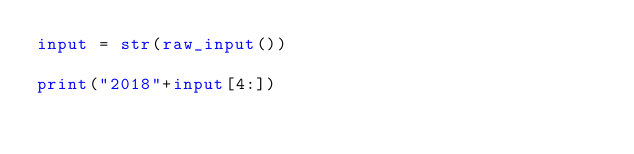<code> <loc_0><loc_0><loc_500><loc_500><_Python_>input = str(raw_input())

print("2018"+input[4:])</code> 